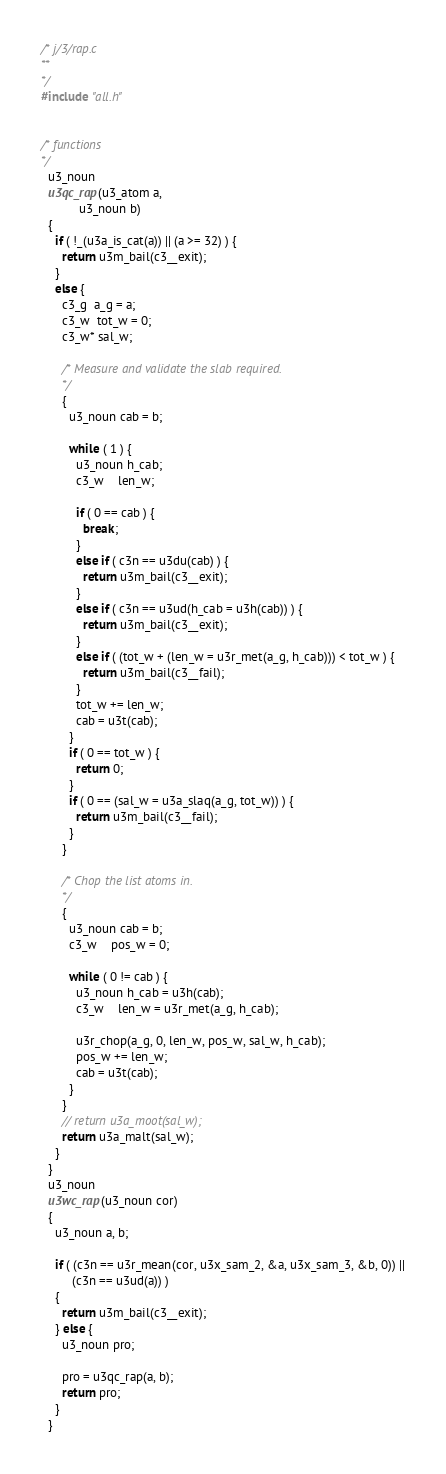Convert code to text. <code><loc_0><loc_0><loc_500><loc_500><_C_>/* j/3/rap.c
**
*/
#include "all.h"


/* functions
*/
  u3_noun
  u3qc_rap(u3_atom a,
           u3_noun b)
  {
    if ( !_(u3a_is_cat(a)) || (a >= 32) ) {
      return u3m_bail(c3__exit);
    }
    else {
      c3_g  a_g = a;
      c3_w  tot_w = 0;
      c3_w* sal_w;

      /* Measure and validate the slab required.
      */
      {
        u3_noun cab = b;

        while ( 1 ) {
          u3_noun h_cab;
          c3_w    len_w;

          if ( 0 == cab ) {
            break;
          }
          else if ( c3n == u3du(cab) ) {
            return u3m_bail(c3__exit);
          }
          else if ( c3n == u3ud(h_cab = u3h(cab)) ) {
            return u3m_bail(c3__exit);
          }
          else if ( (tot_w + (len_w = u3r_met(a_g, h_cab))) < tot_w ) {
            return u3m_bail(c3__fail);
          }
          tot_w += len_w;
          cab = u3t(cab);
        }
        if ( 0 == tot_w ) {
          return 0;
        }
        if ( 0 == (sal_w = u3a_slaq(a_g, tot_w)) ) {
          return u3m_bail(c3__fail);
        }
      }

      /* Chop the list atoms in.
      */
      {
        u3_noun cab = b;
        c3_w    pos_w = 0;

        while ( 0 != cab ) {
          u3_noun h_cab = u3h(cab);
          c3_w    len_w = u3r_met(a_g, h_cab);

          u3r_chop(a_g, 0, len_w, pos_w, sal_w, h_cab);
          pos_w += len_w;
          cab = u3t(cab);
        }
      }
      // return u3a_moot(sal_w);
      return u3a_malt(sal_w);
    }
  }
  u3_noun
  u3wc_rap(u3_noun cor)
  {
    u3_noun a, b;

    if ( (c3n == u3r_mean(cor, u3x_sam_2, &a, u3x_sam_3, &b, 0)) ||
         (c3n == u3ud(a)) )
    {
      return u3m_bail(c3__exit);
    } else {
      u3_noun pro;

      pro = u3qc_rap(a, b);
      return pro;
    }
  }

</code> 